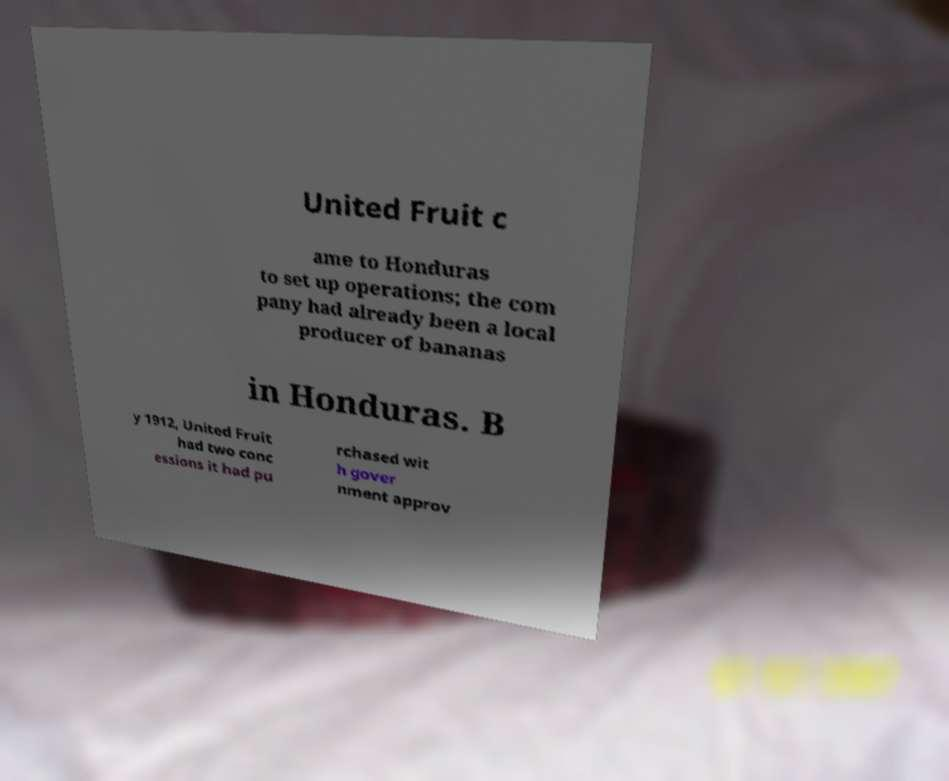There's text embedded in this image that I need extracted. Can you transcribe it verbatim? United Fruit c ame to Honduras to set up operations; the com pany had already been a local producer of bananas in Honduras. B y 1912, United Fruit had two conc essions it had pu rchased wit h gover nment approv 